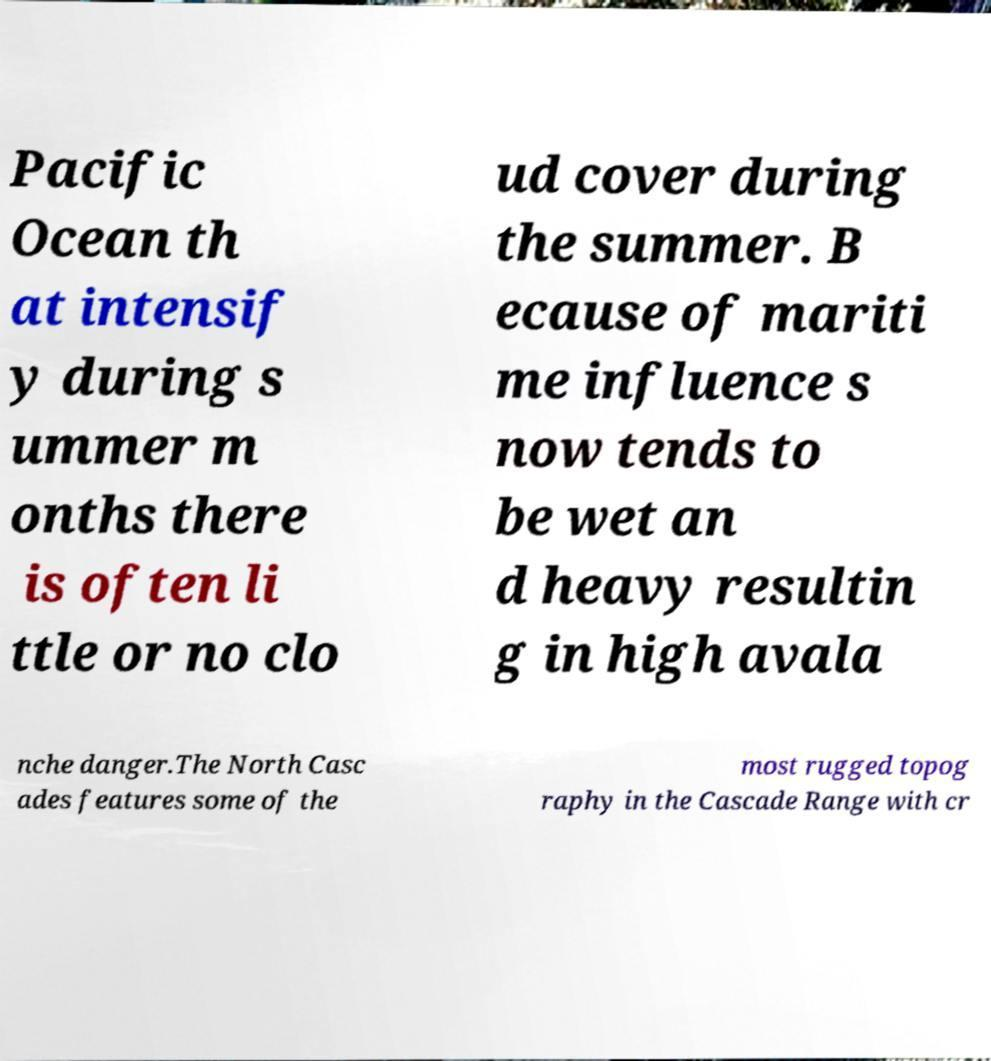Could you assist in decoding the text presented in this image and type it out clearly? Pacific Ocean th at intensif y during s ummer m onths there is often li ttle or no clo ud cover during the summer. B ecause of mariti me influence s now tends to be wet an d heavy resultin g in high avala nche danger.The North Casc ades features some of the most rugged topog raphy in the Cascade Range with cr 